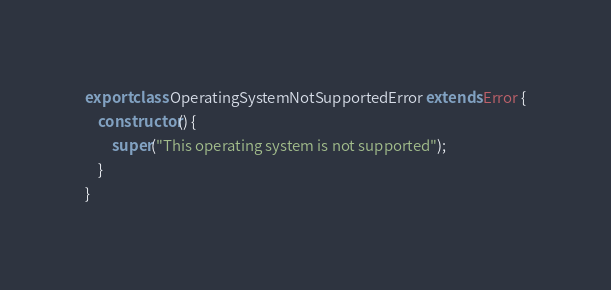Convert code to text. <code><loc_0><loc_0><loc_500><loc_500><_TypeScript_>export class OperatingSystemNotSupportedError extends Error {
    constructor() {
        super("This operating system is not supported");
    }
}
</code> 